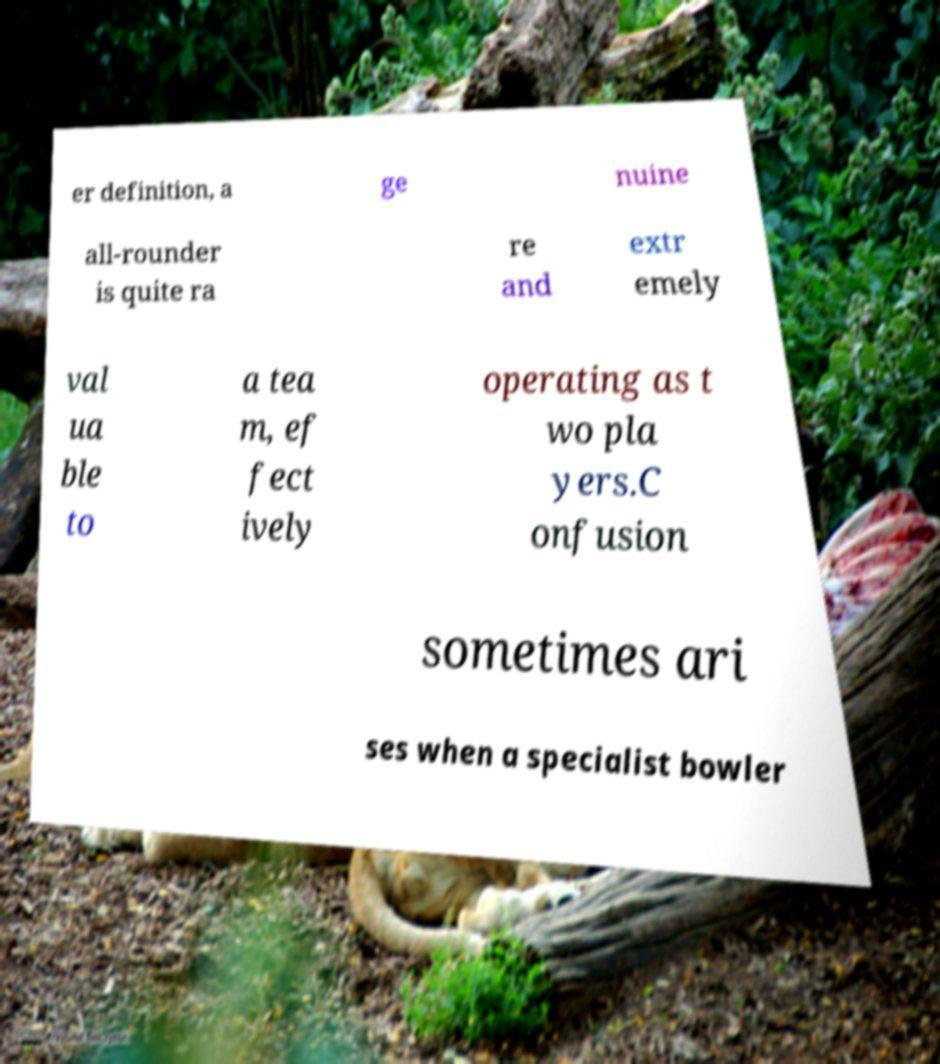Can you read and provide the text displayed in the image?This photo seems to have some interesting text. Can you extract and type it out for me? er definition, a ge nuine all-rounder is quite ra re and extr emely val ua ble to a tea m, ef fect ively operating as t wo pla yers.C onfusion sometimes ari ses when a specialist bowler 